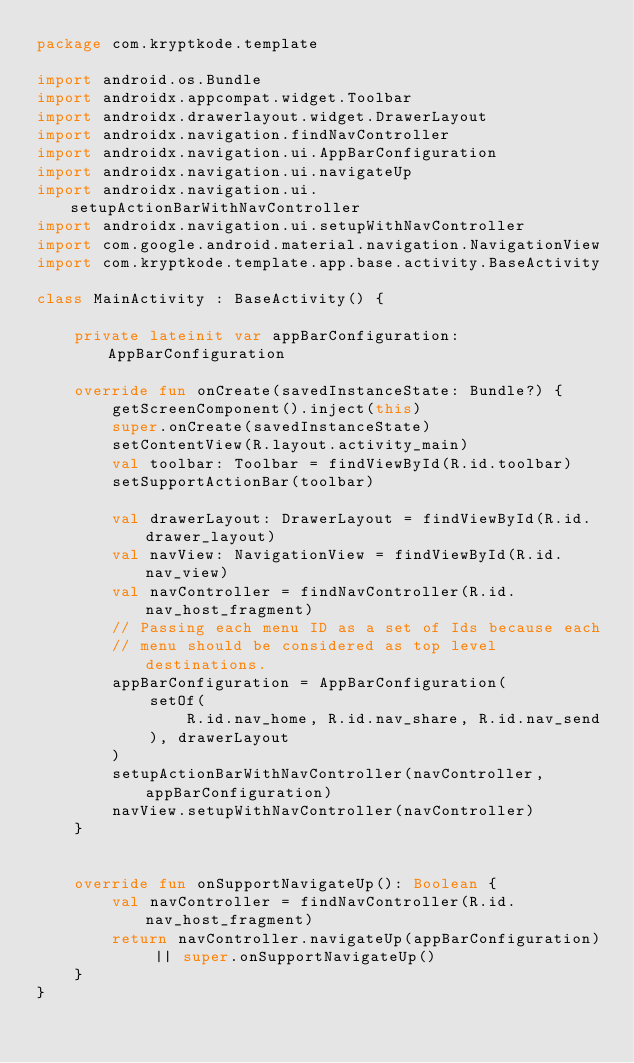Convert code to text. <code><loc_0><loc_0><loc_500><loc_500><_Kotlin_>package com.kryptkode.template

import android.os.Bundle
import androidx.appcompat.widget.Toolbar
import androidx.drawerlayout.widget.DrawerLayout
import androidx.navigation.findNavController
import androidx.navigation.ui.AppBarConfiguration
import androidx.navigation.ui.navigateUp
import androidx.navigation.ui.setupActionBarWithNavController
import androidx.navigation.ui.setupWithNavController
import com.google.android.material.navigation.NavigationView
import com.kryptkode.template.app.base.activity.BaseActivity

class MainActivity : BaseActivity() {

    private lateinit var appBarConfiguration: AppBarConfiguration

    override fun onCreate(savedInstanceState: Bundle?) {
        getScreenComponent().inject(this)
        super.onCreate(savedInstanceState)
        setContentView(R.layout.activity_main)
        val toolbar: Toolbar = findViewById(R.id.toolbar)
        setSupportActionBar(toolbar)

        val drawerLayout: DrawerLayout = findViewById(R.id.drawer_layout)
        val navView: NavigationView = findViewById(R.id.nav_view)
        val navController = findNavController(R.id.nav_host_fragment)
        // Passing each menu ID as a set of Ids because each
        // menu should be considered as top level destinations.
        appBarConfiguration = AppBarConfiguration(
            setOf(
                R.id.nav_home, R.id.nav_share, R.id.nav_send
            ), drawerLayout
        )
        setupActionBarWithNavController(navController, appBarConfiguration)
        navView.setupWithNavController(navController)
    }


    override fun onSupportNavigateUp(): Boolean {
        val navController = findNavController(R.id.nav_host_fragment)
        return navController.navigateUp(appBarConfiguration) || super.onSupportNavigateUp()
    }
}
</code> 